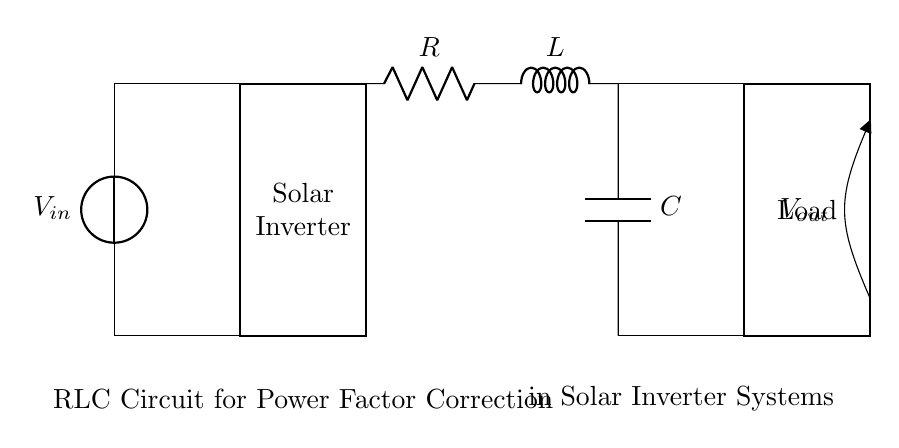What are the components in the circuit? The components in the circuit are a resistor, inductor, and capacitor arranged in series. Each component serves a specific purpose in managing voltage and current for power factor correction.
Answer: resistor, inductor, capacitor What is the function of the RLC circuit in this setup? The RLC circuit is used for power factor correction, enhancing the efficiency of the solar inverter system by minimizing phase differences between current and voltage.
Answer: power factor correction What does the voltage source represent? The voltage source represents the input from the solar panel, providing the energy needed for the entire circuit.
Answer: solar panel What is the configuration of the components in the RLC circuit? The RLC components are connected in series, allowing the current to flow sequentially through the resistor, inductor, and capacitor.
Answer: series Why is power factor correction important in solar inverter systems? Power factor correction is crucial as it optimizes energy transfer, reduces losses, and improves the performance of inverter systems by maintaining an effective current-voltage phase alignment.
Answer: optimizes energy transfer What is the role of the load in this circuit? The load represents the demand for power in the circuit, where the corrected power from the RLC circuit is utilized. This could be any electrical device or system that requires energy.
Answer: demand for power 